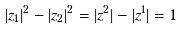<formula> <loc_0><loc_0><loc_500><loc_500>| z _ { 1 } | ^ { 2 } - | z _ { 2 } | ^ { 2 } = | z ^ { 2 } | - | z ^ { 1 } | = 1</formula> 